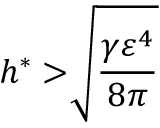<formula> <loc_0><loc_0><loc_500><loc_500>h ^ { \ast } > \sqrt { [ } ] { \frac { \gamma \varepsilon ^ { 4 } } { 8 \pi } }</formula> 